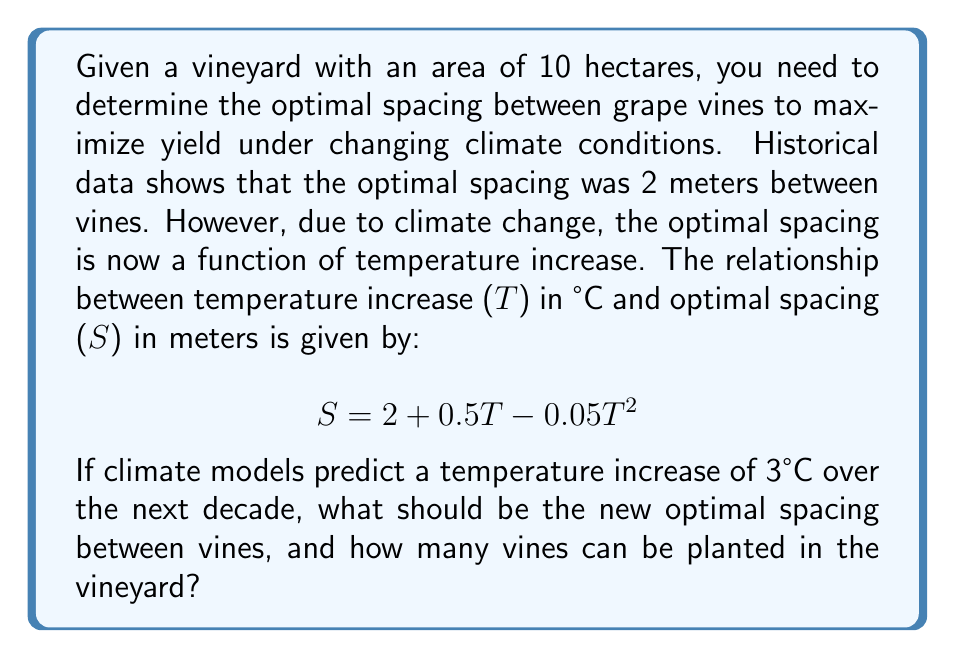Provide a solution to this math problem. 1. Calculate the new optimal spacing:
   Given: $S = 2 + 0.5T - 0.05T^2$, where $T = 3$°C
   $$ S = 2 + 0.5(3) - 0.05(3^2) $$
   $$ S = 2 + 1.5 - 0.45 $$
   $$ S = 3.05 \text{ meters} $$

2. Convert vineyard area to square meters:
   10 hectares = 100,000 m²

3. Calculate the number of vines that can be planted:
   Assume a square grid pattern for planting.
   Area per vine = $S^2 = 3.05^2 = 9.3025 \text{ m}^2$

   Number of vines = Total area / Area per vine
   $$ \text{Number of vines} = \frac{100,000 \text{ m}^2}{9.3025 \text{ m}^2} $$
   $$ \text{Number of vines} = 10,749.6 $$

4. Round down to the nearest whole number:
   Number of vines = 10,749
Answer: 3.05 meters; 10,749 vines 